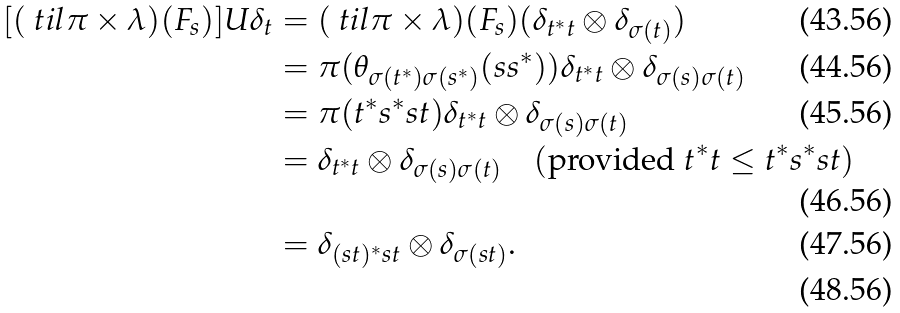Convert formula to latex. <formula><loc_0><loc_0><loc_500><loc_500>[ ( \ t i l \pi \times \lambda ) ( F _ { s } ) ] U \delta _ { t } & = ( \ t i l \pi \times \lambda ) ( F _ { s } ) ( \delta _ { t ^ { * } t } \otimes \delta _ { \sigma ( t ) } ) \\ & = \pi ( \theta _ { \sigma ( t ^ { * } ) \sigma ( s ^ { * } ) } ( s s ^ { * } ) ) \delta _ { t ^ { * } t } \otimes \delta _ { \sigma ( s ) \sigma ( t ) } \\ & = \pi ( t ^ { * } s ^ { * } s t ) \delta _ { t ^ { * } t } \otimes \delta _ { \sigma ( s ) \sigma ( t ) } \\ & = \delta _ { t ^ { * } t } \otimes \delta _ { \sigma ( s ) \sigma ( t ) } \quad ( \text {provided} \ t ^ { * } t \leq t ^ { * } s ^ { * } s t ) \\ & = \delta _ { ( s t ) ^ { * } s t } \otimes \delta _ { \sigma ( s t ) } . \\</formula> 